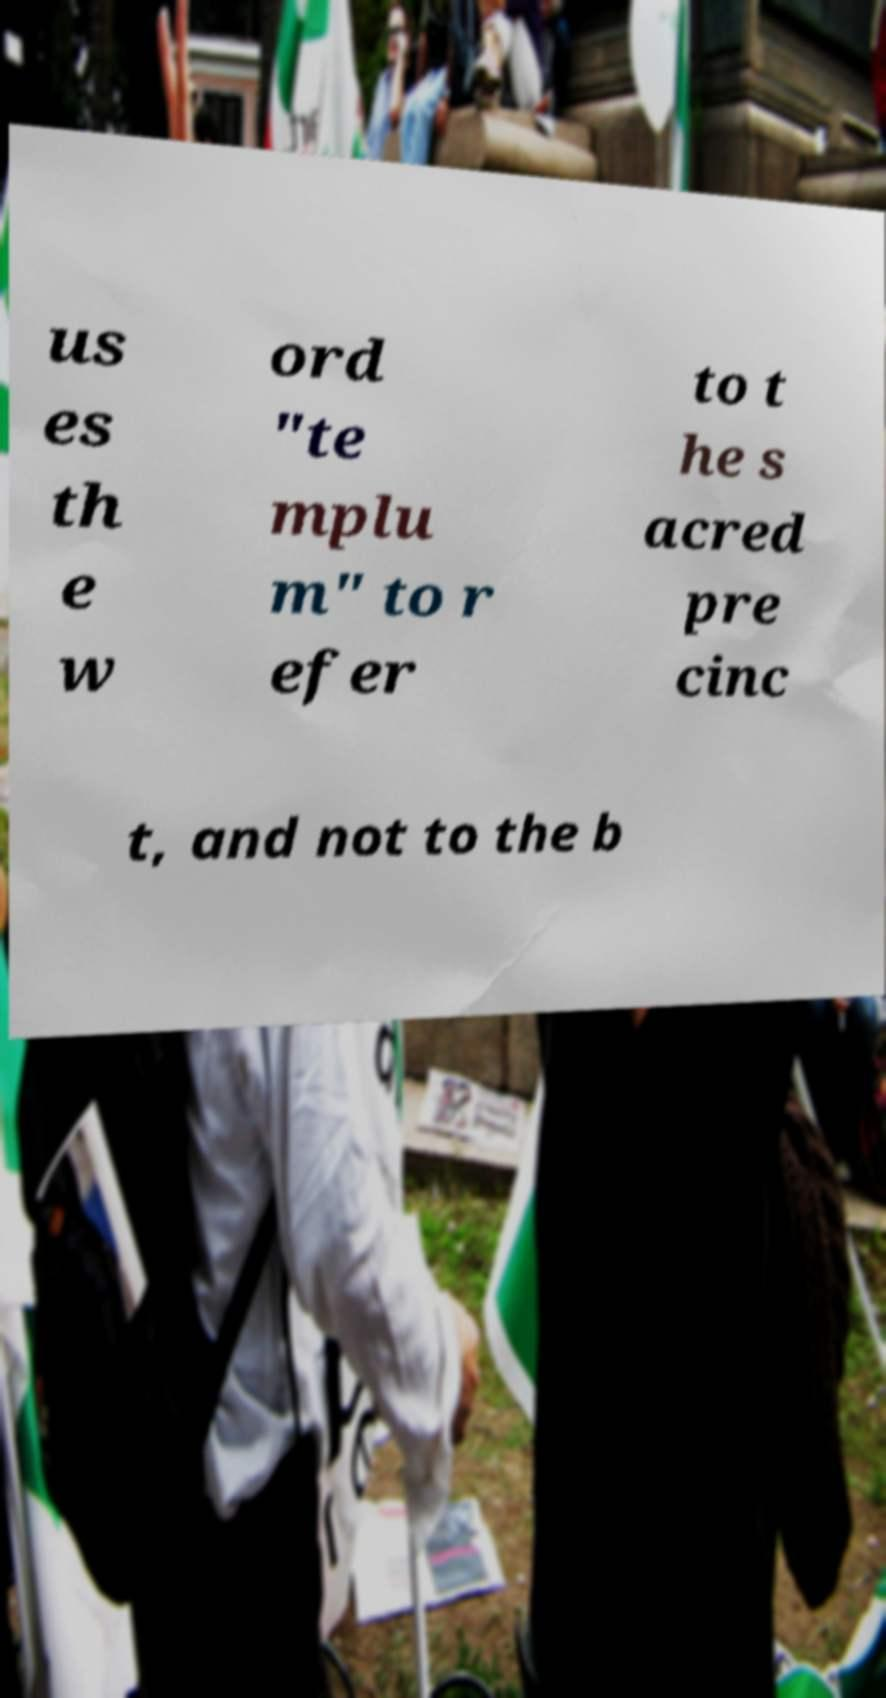Please identify and transcribe the text found in this image. us es th e w ord "te mplu m" to r efer to t he s acred pre cinc t, and not to the b 